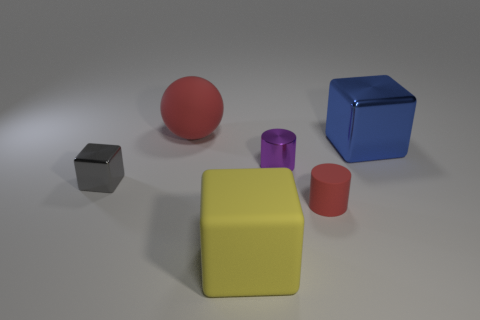Is there a metallic cube of the same color as the tiny shiny cylinder?
Your response must be concise. No. What is the shape of the yellow thing that is the same size as the blue shiny block?
Your answer should be very brief. Cube. Is the number of gray metal blocks less than the number of tiny blue metallic objects?
Ensure brevity in your answer.  No. How many other rubber spheres have the same size as the red ball?
Keep it short and to the point. 0. What is the shape of the big thing that is the same color as the small rubber object?
Offer a very short reply. Sphere. What is the material of the yellow object?
Your response must be concise. Rubber. What is the size of the red rubber object behind the tiny red cylinder?
Offer a terse response. Large. How many blue things are the same shape as the yellow matte thing?
Make the answer very short. 1. What is the shape of the tiny red thing that is made of the same material as the sphere?
Offer a terse response. Cylinder. How many red things are either big balls or metallic balls?
Offer a very short reply. 1. 